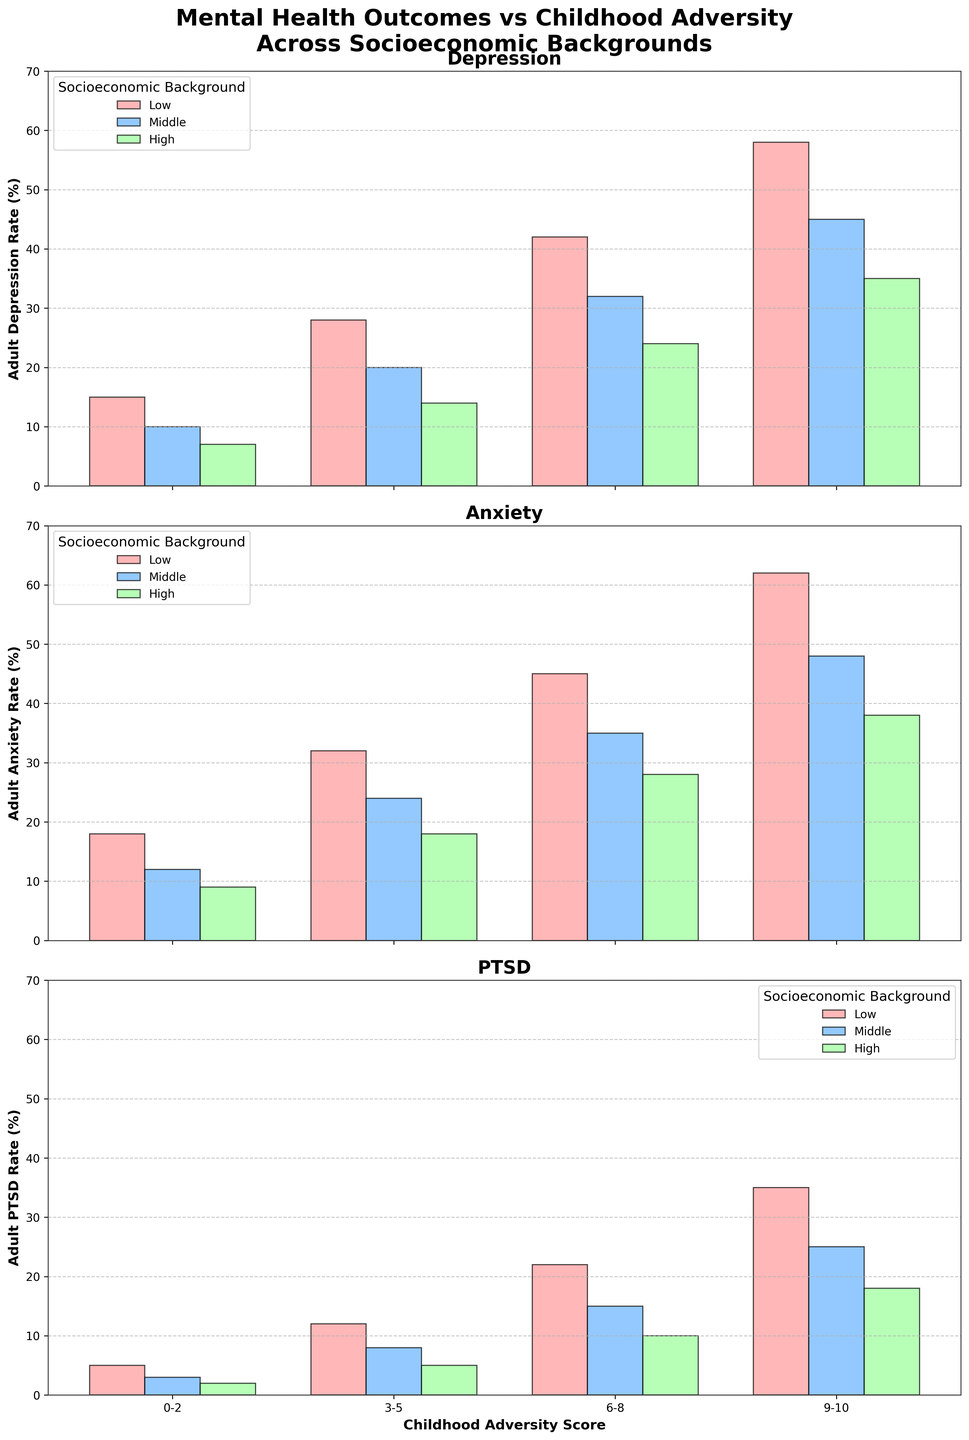What's the overall trend in adult depression rates as childhood adversity scores increase for all socioeconomic backgrounds? By observing the bars across all subplots, it's clear that as childhood adversity scores increase, the adult depression rates also increase correspondingly for all socioeconomic backgrounds.
Answer: Increasing trend Which socioeconomic background has the highest adult PTSD rate at a childhood adversity score of 6-8? Look at the third set of bars in the PTSD subplot corresponding to the 6-8 adversity score and identify which color (light green, blue, red) has the tallest bar. The tallest bar is light green, corresponding to the 'Low' socioeconomic background.
Answer: Low How does adult anxiety rate for middle socioeconomic background compare to high socioeconomic background at the highest childhood adversity score? On the anxiety subplot, compare the heights of the bars for 'Middle' (blue) and 'High' (green) at the 9-10 childhood adversity score. The blue bar (Middle) is higher than the green bar (High).
Answer: Higher What's the difference in adult depression rates between low and high socioeconomic backgrounds at a childhood adversity score of 3-5? In the depression subplot, identify the heights of the bars for 'Low' (red) and 'High' (green) at the 3-5 childhood adversity score. Subtract the rate for High (14) from Low (28). 28 - 14 = 14
Answer: 14 Which childhood adversity score range shows the least difference in adult anxiety rates between middle and low socioeconomic backgrounds? Compare the differences in heights of the blue (Middle) and red (Low) bars in the anxiety subplot for each childhood adversity score range. The smallest difference is seen at the 0-2 score range (12 for Middle, 18 for Low, difference of 6).
Answer: 0-2 What is the average adult PTSD rate for high socioeconomic background across all childhood adversity scores? Calculate the average by summing PTSD rates for High socioeconomic background (2 + 5 + 10 + 18) and dividing by the number of data points (4). Average = (2 + 5 + 10 + 18)/4 = 8.75
Answer: 8.75 What's the general pattern in adult mental health outcomes when comparing low vs high socioeconomic backgrounds at the highest childhood adversity score? Observe the bars for Low and High backgrounds at the 9-10 childhood adversity score across all subplots. Low consistently shows higher values than High for depression, anxiety, and PTSD.
Answer: Low consistently higher Between which childhood adversity scores do we see the steepest increase in adult depression rates for middle socioeconomic background? Look at the heights of bars for the middle background in the depression subplot and identify the range with the largest height difference. The steepest increase occurs between 6-8 (32) and 9-10 (45).
Answer: 6-8 to 9-10 